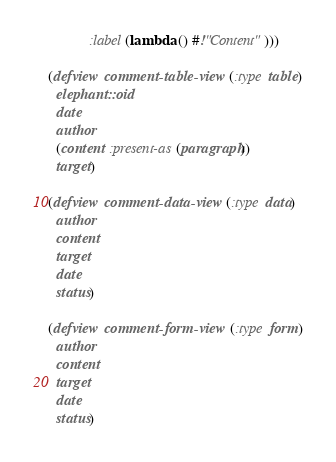<code> <loc_0><loc_0><loc_500><loc_500><_Lisp_>           :label (lambda () #!"Content")))

(defview comment-table-view (:type table)
  elephant::oid
  date
  author
  (content :present-as (paragraph))
  target)

(defview comment-data-view (:type data)
  author
  content
  target
  date
  status)

(defview comment-form-view (:type form)
  author
  content
  target
  date
  status)
</code> 